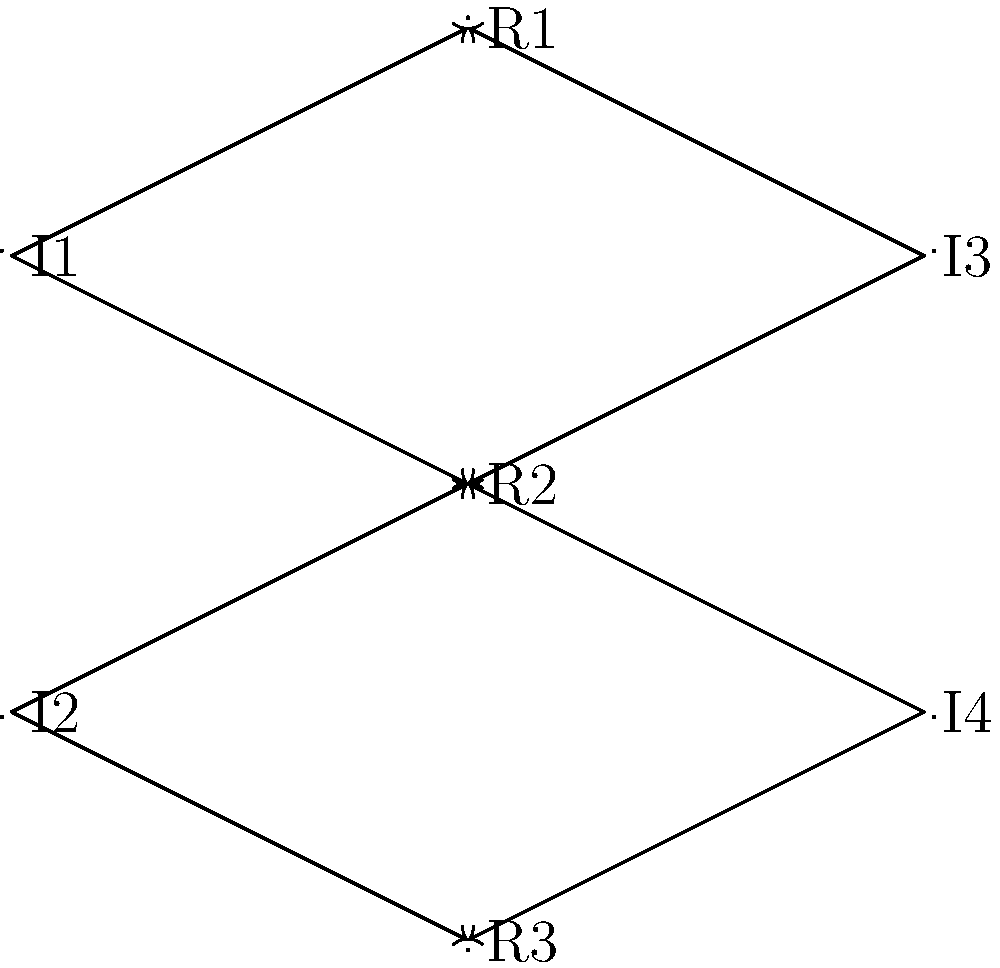In the network diagram above, nodes R1, R2, and R3 represent potential recruits, while I1, I2, I3, and I4 represent social media influencers. Arrows indicate which influencers have connections to which recruits. Based on this diagram, which recruit has the most diverse set of influencer connections, potentially indicating a broader network and higher social media engagement? To determine which recruit has the most diverse set of influencer connections, we need to count the number of unique influencers connected to each recruit:

1. For R1:
   - Connected to I1 and I3
   - Total unique influencers: 2

2. For R2:
   - Connected to I1, I2, I3, and I4
   - Total unique influencers: 4

3. For R3:
   - Connected to I2 and I4
   - Total unique influencers: 2

R2 has the highest number of unique influencer connections (4), compared to R1 and R3 (2 each). This suggests that R2 has the most diverse set of influencer connections, potentially indicating a broader network and higher social media engagement.
Answer: R2 